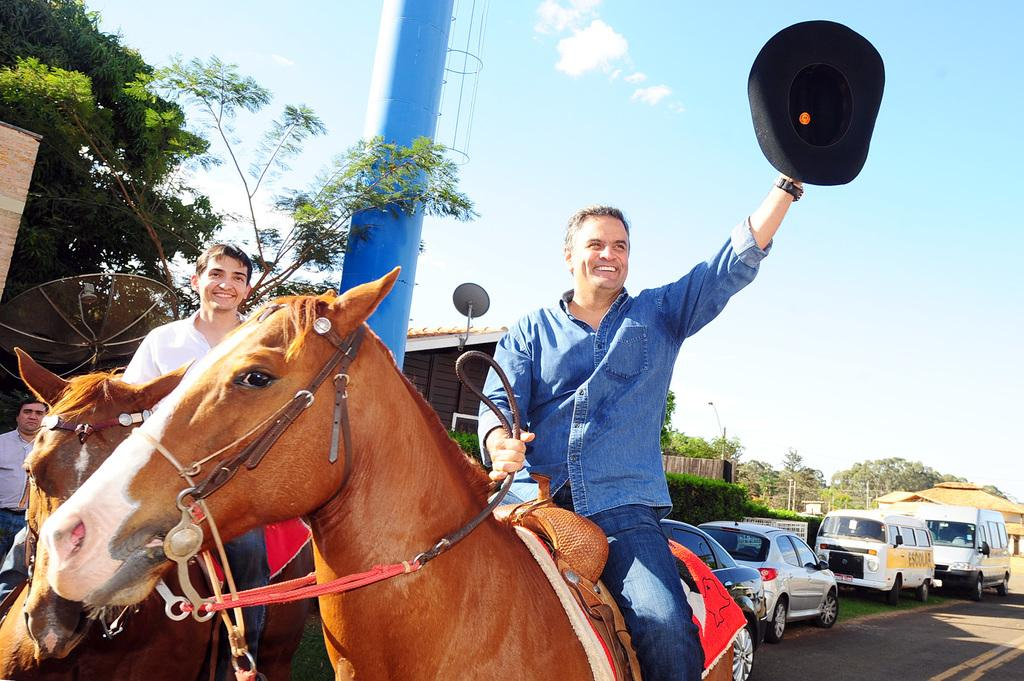How many men are in the image? There are two men in the image. What are the men doing in the image? The men are sitting on horses. What is the right side man holding in his hand? The right side man is holding a cap in his hand. What type of vegetation can be seen in the image? There are many trees around in the image. What type of modern transportation is visible in the image? Cars are visible in the image. What type of ground surface is present in the image? Grass is present in the image. Where is the shop located in the image? There is no shop present in the image. What type of bun is being held by one of the men in the image? There is no bun present in the image; the right side man is holding a cap. 